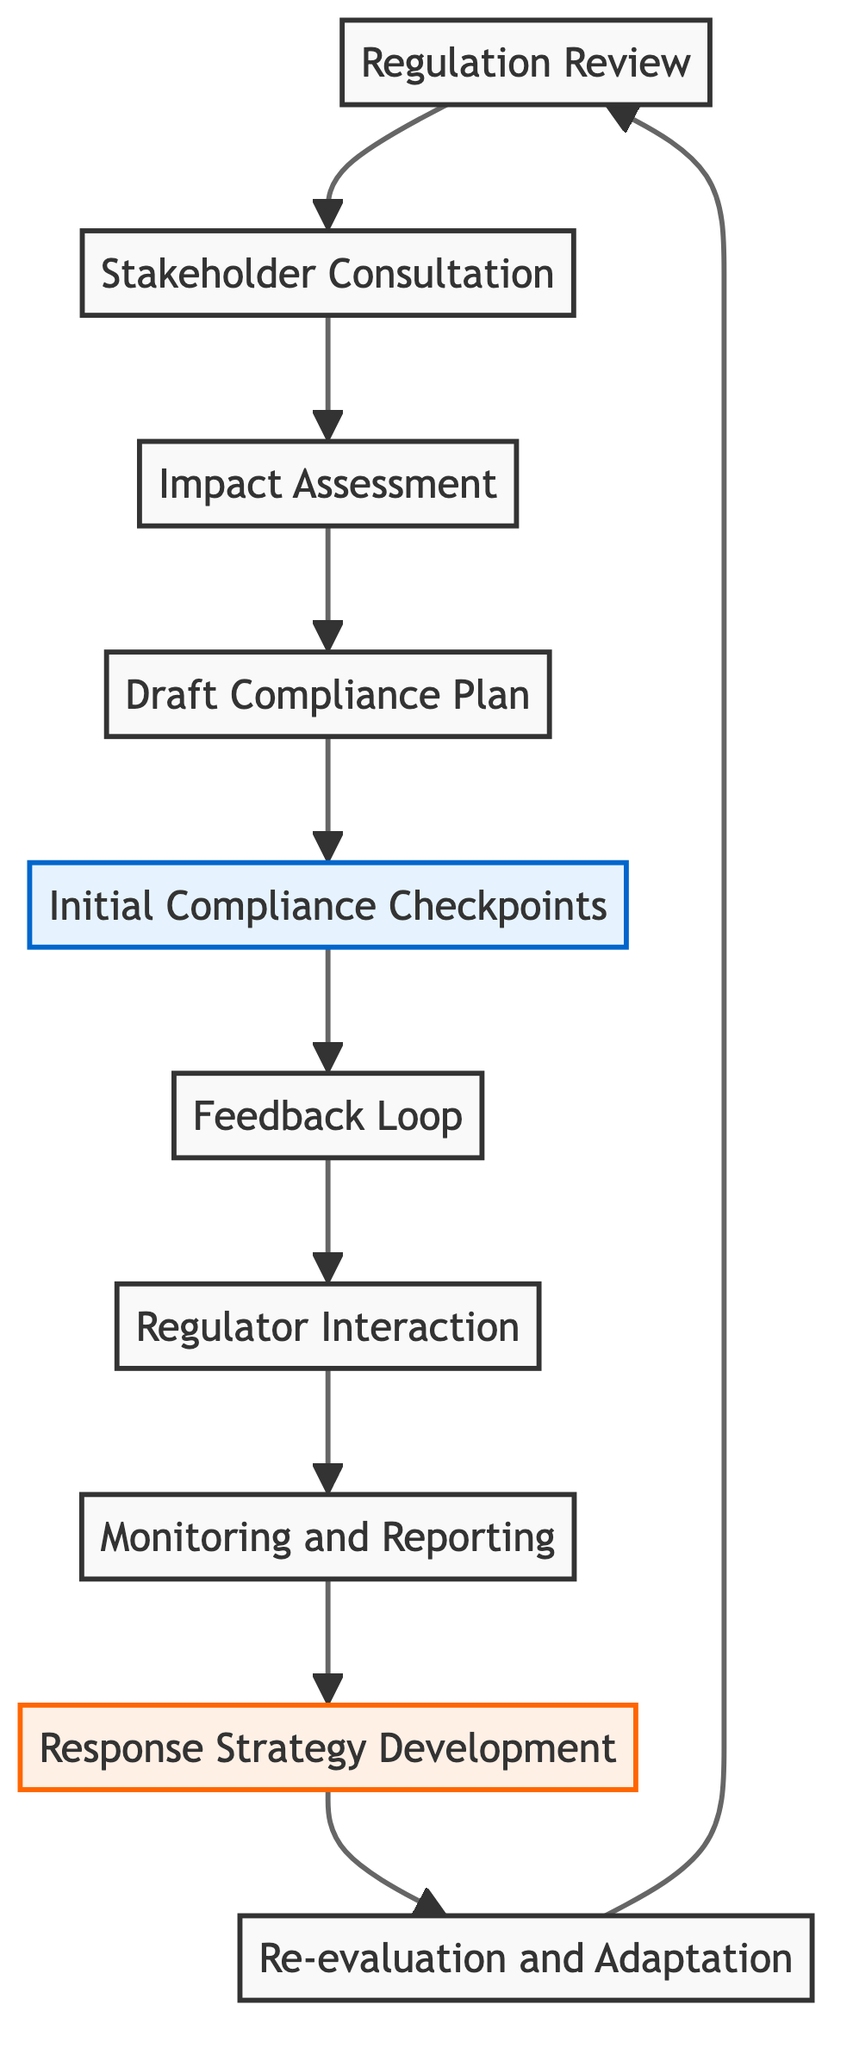What is the first step in the flow? The first step in the flow is "Regulation Review," which assesses new government regulations.
Answer: Regulation Review How many total elements are in the flowchart? There are ten elements depicted in the flowchart, which include various steps from regulation review to adaptation.
Answer: Ten Which element comes immediately after "Impact Assessment"? The "Draft Compliance Plan" follows the "Impact Assessment" in the flow sequence.
Answer: Draft Compliance Plan What type of check is established after the "Draft Compliance Plan"? The "Initial Compliance Checkpoints" are established after the "Draft Compliance Plan" to ensure compliance readiness.
Answer: Initial Compliance Checkpoints What is the purpose of the "Feedback Loop"? The "Feedback Loop" serves to create a mechanism for ongoing feedback and adjustments to the compliance plan.
Answer: Continuous feedback How many strategies are named in the flowchart? There is one strategy named, which is "Response Strategy Development" for addressing non-compliance issues.
Answer: One What does "Regulator Interaction" ensure? "Regulator Interaction" ensures open communication with regulatory bodies for clarity on compliance requirements.
Answer: Open communication What occurs after "Monitoring and Reporting"? Following "Monitoring and Reporting," the next step is "Response Strategy Development" to address potential compliance issues.
Answer: Response Strategy Development What is periodically re-evaluated according to the flow? The "Compliance Plan" is periodically re-evaluated to ensure its effectiveness and adaptability to new regulations.
Answer: Compliance Plan 